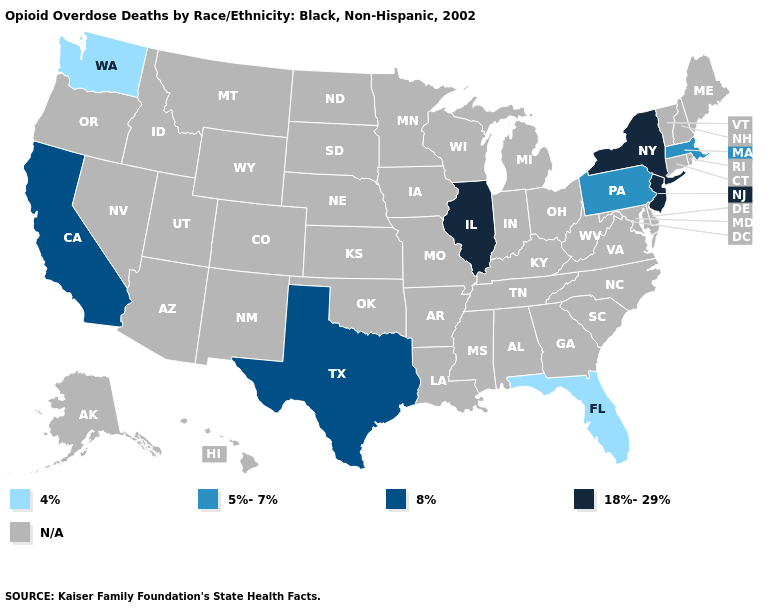Does New Jersey have the highest value in the Northeast?
Write a very short answer. Yes. Which states hav the highest value in the South?
Quick response, please. Texas. Name the states that have a value in the range 4%?
Concise answer only. Florida, Washington. Does Washington have the lowest value in the West?
Write a very short answer. Yes. What is the highest value in the West ?
Keep it brief. 8%. Does the first symbol in the legend represent the smallest category?
Concise answer only. Yes. Does the map have missing data?
Write a very short answer. Yes. Name the states that have a value in the range 18%-29%?
Short answer required. Illinois, New Jersey, New York. How many symbols are there in the legend?
Answer briefly. 5. What is the highest value in the West ?
Give a very brief answer. 8%. Among the states that border Delaware , which have the highest value?
Give a very brief answer. New Jersey. Is the legend a continuous bar?
Answer briefly. No. 